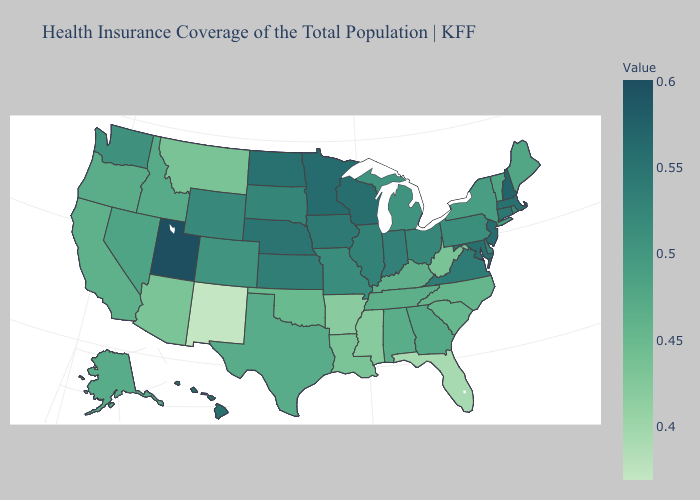Does Kentucky have the highest value in the USA?
Keep it brief. No. Does Kansas have the lowest value in the MidWest?
Concise answer only. No. Among the states that border Vermont , which have the lowest value?
Give a very brief answer. New York. Which states have the highest value in the USA?
Concise answer only. Utah. Among the states that border Maine , which have the highest value?
Give a very brief answer. New Hampshire. 